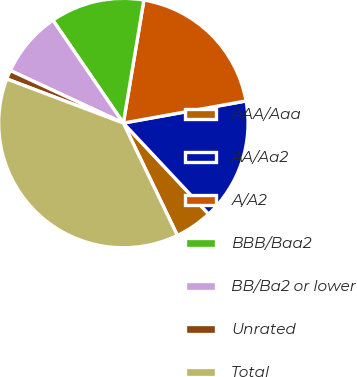<chart> <loc_0><loc_0><loc_500><loc_500><pie_chart><fcel>AAA/Aaa<fcel>AA/Aa2<fcel>A/A2<fcel>BBB/Baa2<fcel>BB/Ba2 or lower<fcel>Unrated<fcel>Total<nl><fcel>4.85%<fcel>15.86%<fcel>19.53%<fcel>12.19%<fcel>8.52%<fcel>1.17%<fcel>37.89%<nl></chart> 